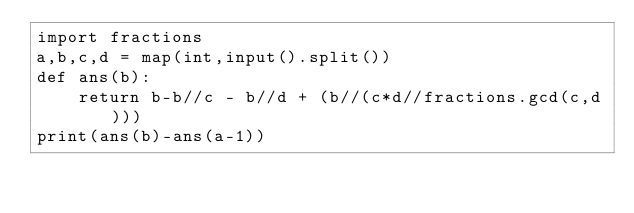<code> <loc_0><loc_0><loc_500><loc_500><_Python_>import fractions
a,b,c,d = map(int,input().split())
def ans(b):
    return b-b//c - b//d + (b//(c*d//fractions.gcd(c,d)))
print(ans(b)-ans(a-1))</code> 